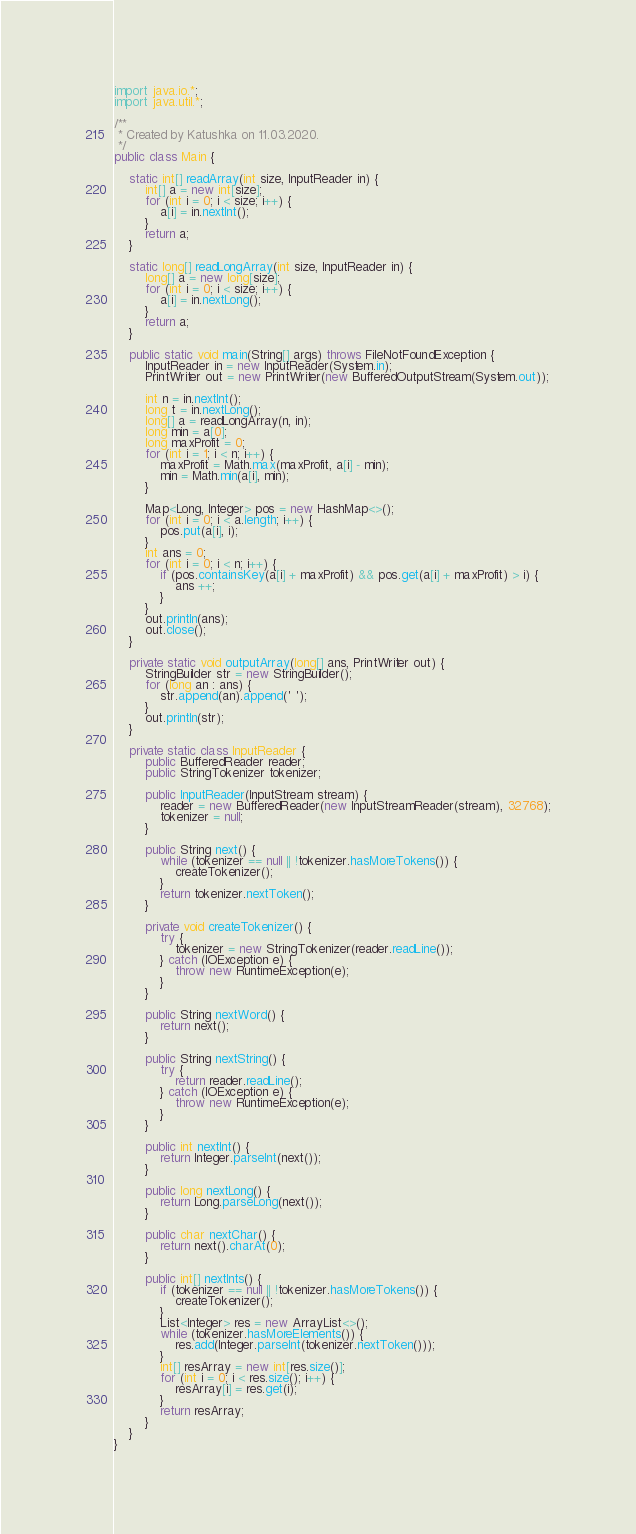<code> <loc_0><loc_0><loc_500><loc_500><_Java_>

import java.io.*;
import java.util.*;

/**
 * Created by Katushka on 11.03.2020.
 */
public class Main {

    static int[] readArray(int size, InputReader in) {
        int[] a = new int[size];
        for (int i = 0; i < size; i++) {
            a[i] = in.nextInt();
        }
        return a;
    }

    static long[] readLongArray(int size, InputReader in) {
        long[] a = new long[size];
        for (int i = 0; i < size; i++) {
            a[i] = in.nextLong();
        }
        return a;
    }

    public static void main(String[] args) throws FileNotFoundException {
        InputReader in = new InputReader(System.in);
        PrintWriter out = new PrintWriter(new BufferedOutputStream(System.out));

        int n = in.nextInt();
        long t = in.nextLong();
        long[] a = readLongArray(n, in);
        long min = a[0];
        long maxProfit = 0;
        for (int i = 1; i < n; i++) {
            maxProfit = Math.max(maxProfit, a[i] - min);
            min = Math.min(a[i], min);
        }

        Map<Long, Integer> pos = new HashMap<>();
        for (int i = 0; i < a.length; i++) {
            pos.put(a[i], i);
        }
        int ans = 0;
        for (int i = 0; i < n; i++) {
            if (pos.containsKey(a[i] + maxProfit) && pos.get(a[i] + maxProfit) > i) {
                ans ++;
            }
        }
        out.println(ans);
        out.close();
    }

    private static void outputArray(long[] ans, PrintWriter out) {
        StringBuilder str = new StringBuilder();
        for (long an : ans) {
            str.append(an).append(' ');
        }
        out.println(str);
    }

    private static class InputReader {
        public BufferedReader reader;
        public StringTokenizer tokenizer;

        public InputReader(InputStream stream) {
            reader = new BufferedReader(new InputStreamReader(stream), 32768);
            tokenizer = null;
        }

        public String next() {
            while (tokenizer == null || !tokenizer.hasMoreTokens()) {
                createTokenizer();
            }
            return tokenizer.nextToken();
        }

        private void createTokenizer() {
            try {
                tokenizer = new StringTokenizer(reader.readLine());
            } catch (IOException e) {
                throw new RuntimeException(e);
            }
        }

        public String nextWord() {
            return next();
        }

        public String nextString() {
            try {
                return reader.readLine();
            } catch (IOException e) {
                throw new RuntimeException(e);
            }
        }

        public int nextInt() {
            return Integer.parseInt(next());
        }

        public long nextLong() {
            return Long.parseLong(next());
        }

        public char nextChar() {
            return next().charAt(0);
        }

        public int[] nextInts() {
            if (tokenizer == null || !tokenizer.hasMoreTokens()) {
                createTokenizer();
            }
            List<Integer> res = new ArrayList<>();
            while (tokenizer.hasMoreElements()) {
                res.add(Integer.parseInt(tokenizer.nextToken()));
            }
            int[] resArray = new int[res.size()];
            for (int i = 0; i < res.size(); i++) {
                resArray[i] = res.get(i);
            }
            return resArray;
        }
    }
}</code> 